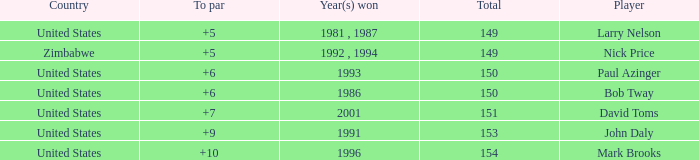What is Zimbabwe's total with a to par higher than 5? None. 